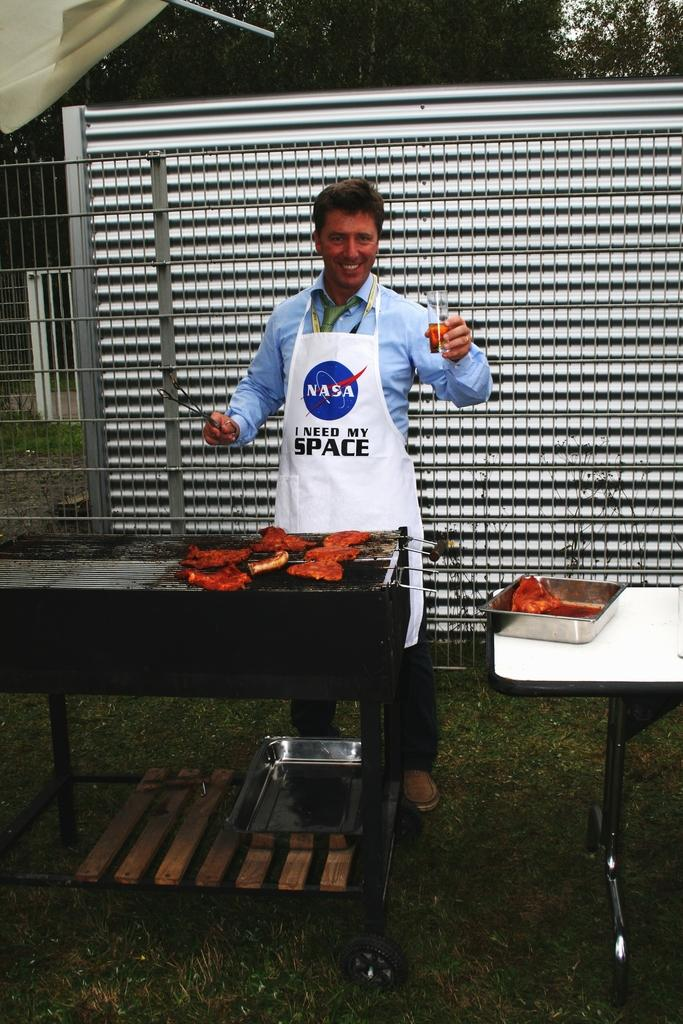<image>
Describe the image concisely. A man in a "NASA - I need my space" apron barbecuing ribs on a grill. 